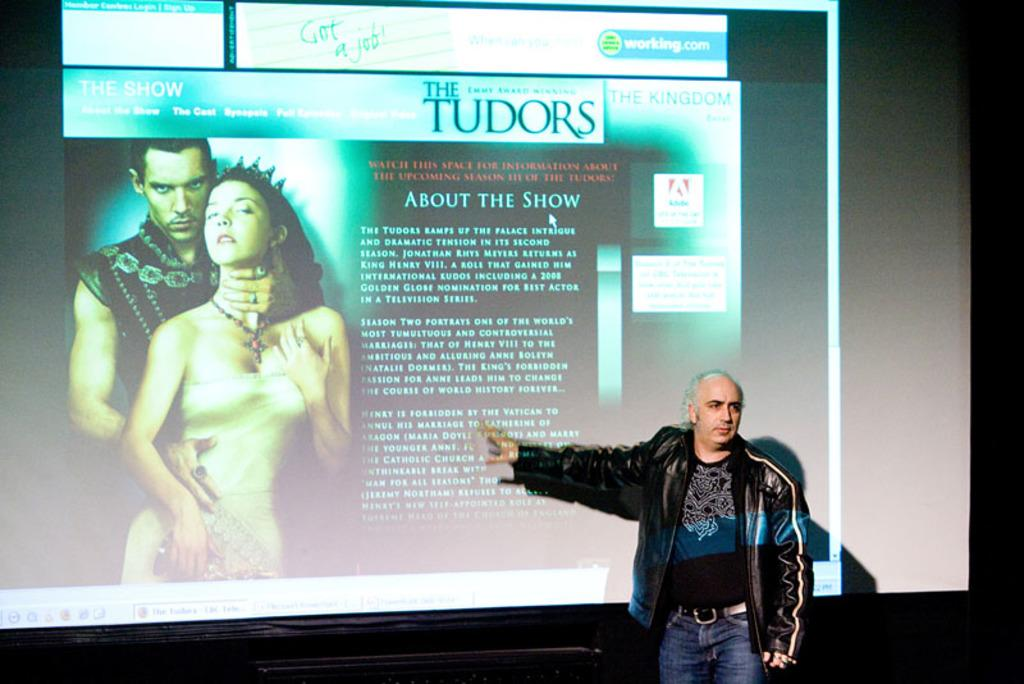What is the position of the person in the image? There is a person standing at the bottom of the image. What can be seen on the screen in the image? There is a screen visible in the image, and text is present on it. How many people are visible on the screen? Two persons are standing in the screen. What type of cream is being used by the person in the image? There is no cream present in the image; it only features a person standing at the bottom and a screen with text and two people. 